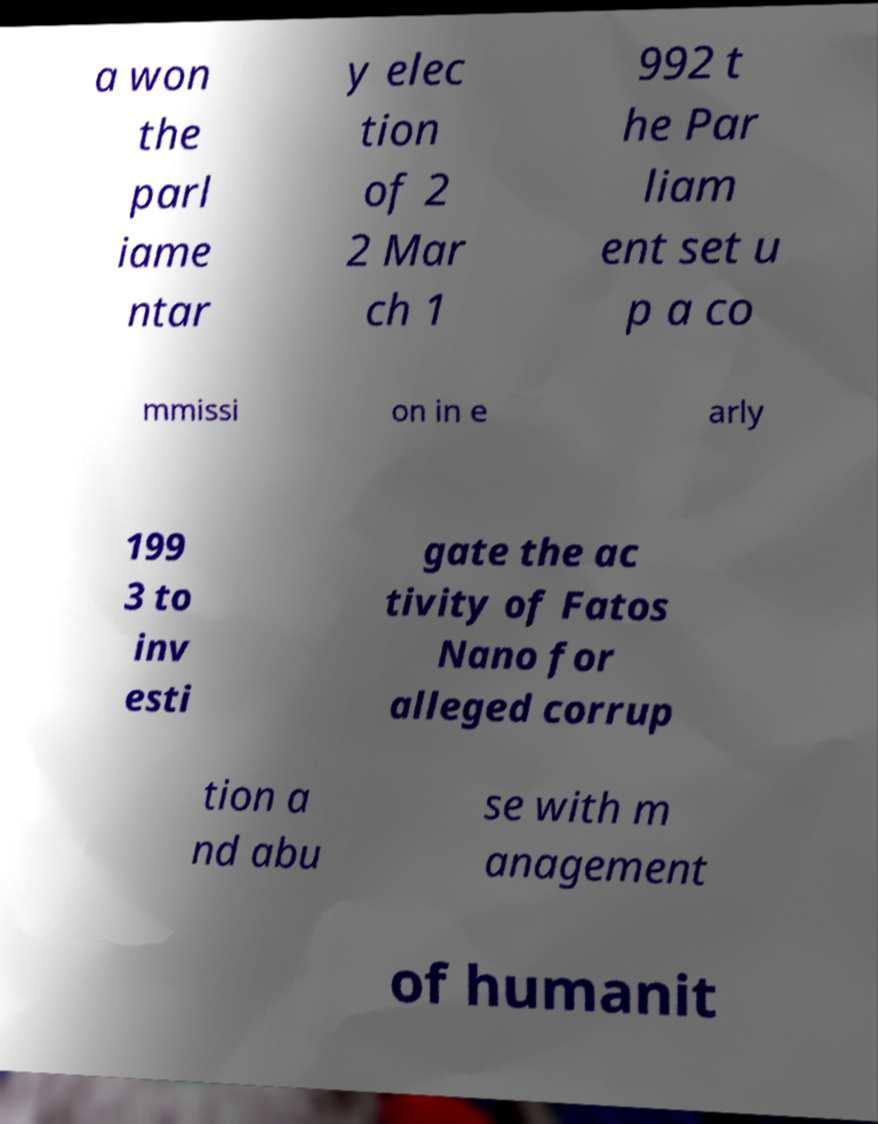There's text embedded in this image that I need extracted. Can you transcribe it verbatim? a won the parl iame ntar y elec tion of 2 2 Mar ch 1 992 t he Par liam ent set u p a co mmissi on in e arly 199 3 to inv esti gate the ac tivity of Fatos Nano for alleged corrup tion a nd abu se with m anagement of humanit 